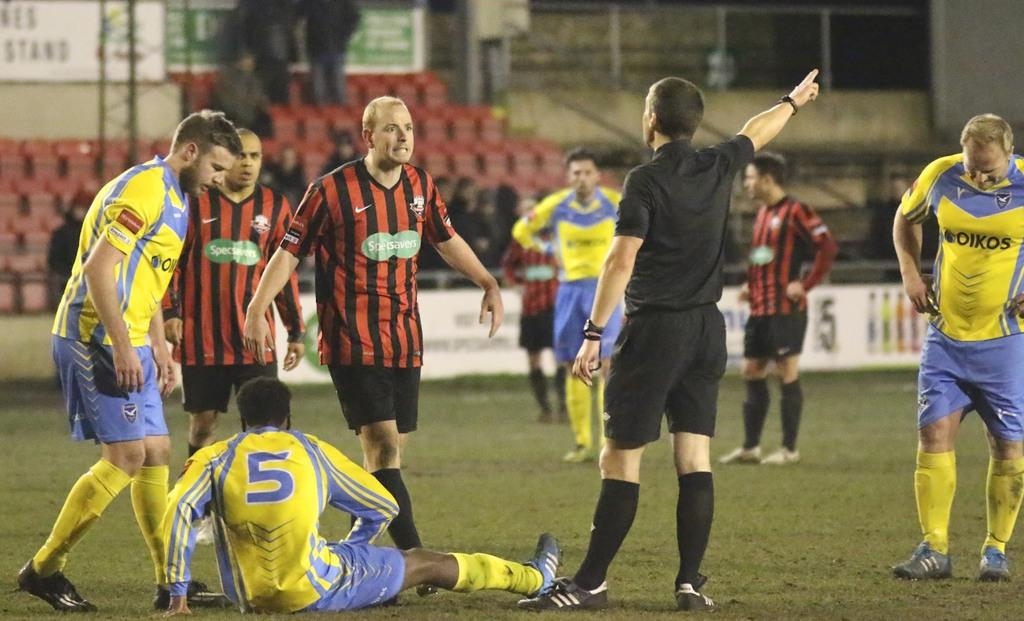<image>
Relay a brief, clear account of the picture shown. A soccer player with number 5 is sitting on the field surrounded by refs and other players. 